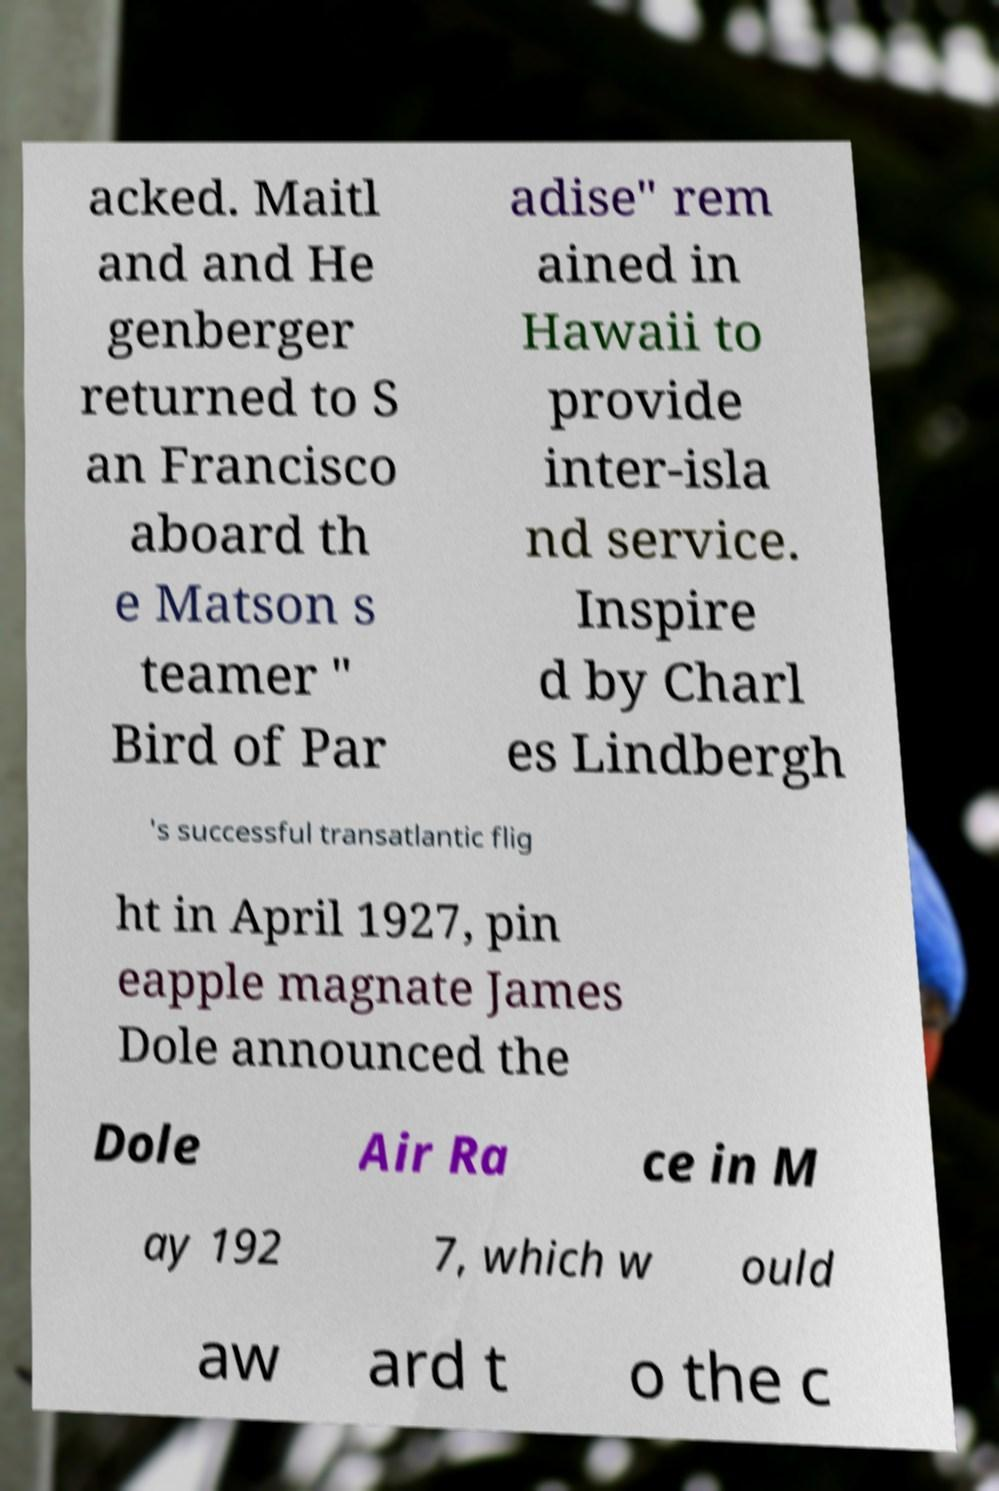Please identify and transcribe the text found in this image. acked. Maitl and and He genberger returned to S an Francisco aboard th e Matson s teamer " Bird of Par adise" rem ained in Hawaii to provide inter-isla nd service. Inspire d by Charl es Lindbergh 's successful transatlantic flig ht in April 1927, pin eapple magnate James Dole announced the Dole Air Ra ce in M ay 192 7, which w ould aw ard t o the c 